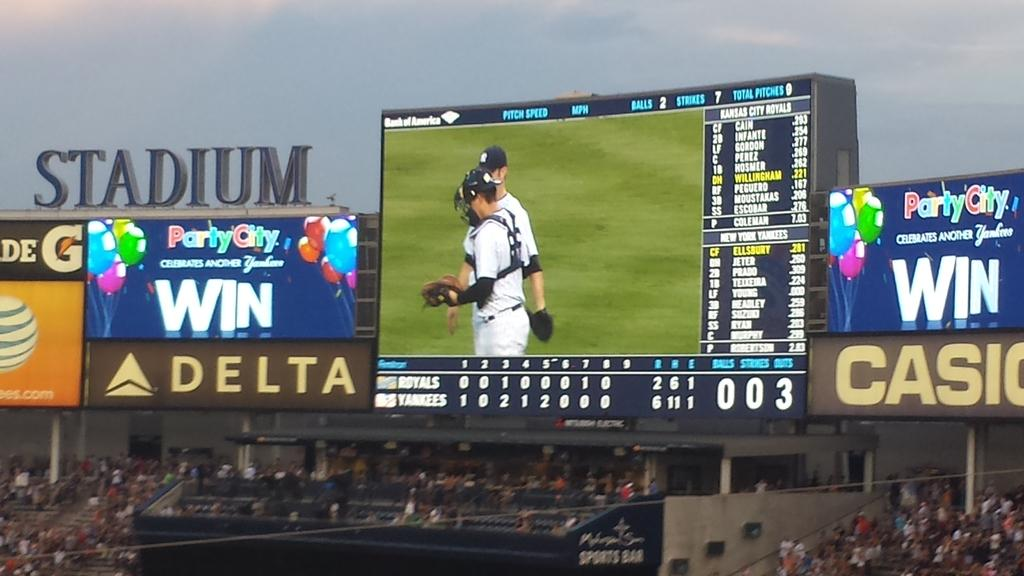Provide a one-sentence caption for the provided image. A baseball stadium with a Delta Ad and a large screen above the stands. 